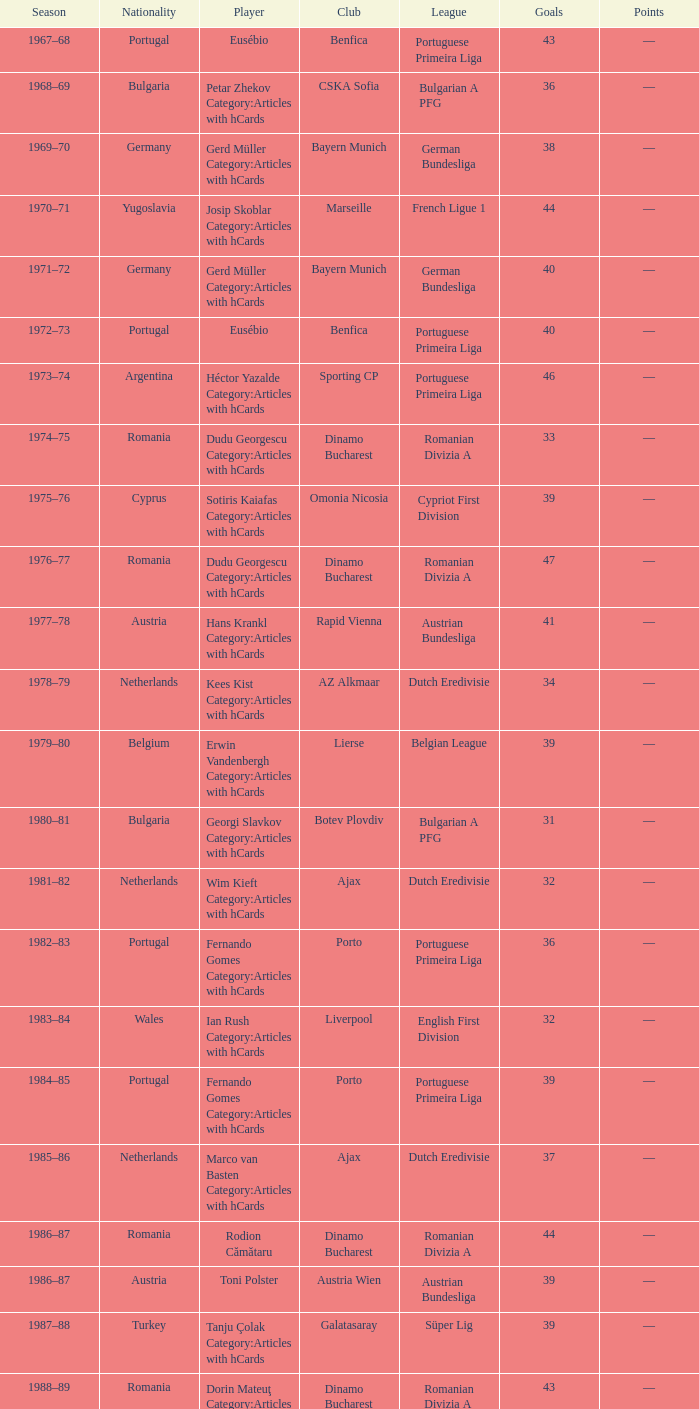Which player was in the Omonia Nicosia club? Sotiris Kaiafas Category:Articles with hCards. 